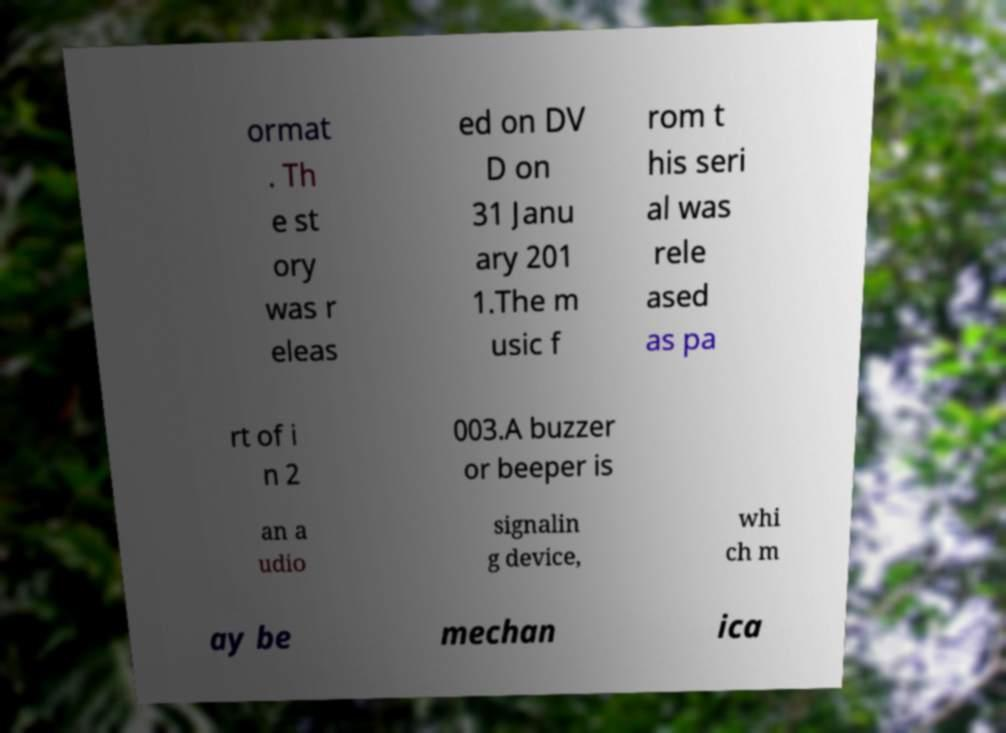I need the written content from this picture converted into text. Can you do that? ormat . Th e st ory was r eleas ed on DV D on 31 Janu ary 201 1.The m usic f rom t his seri al was rele ased as pa rt of i n 2 003.A buzzer or beeper is an a udio signalin g device, whi ch m ay be mechan ica 